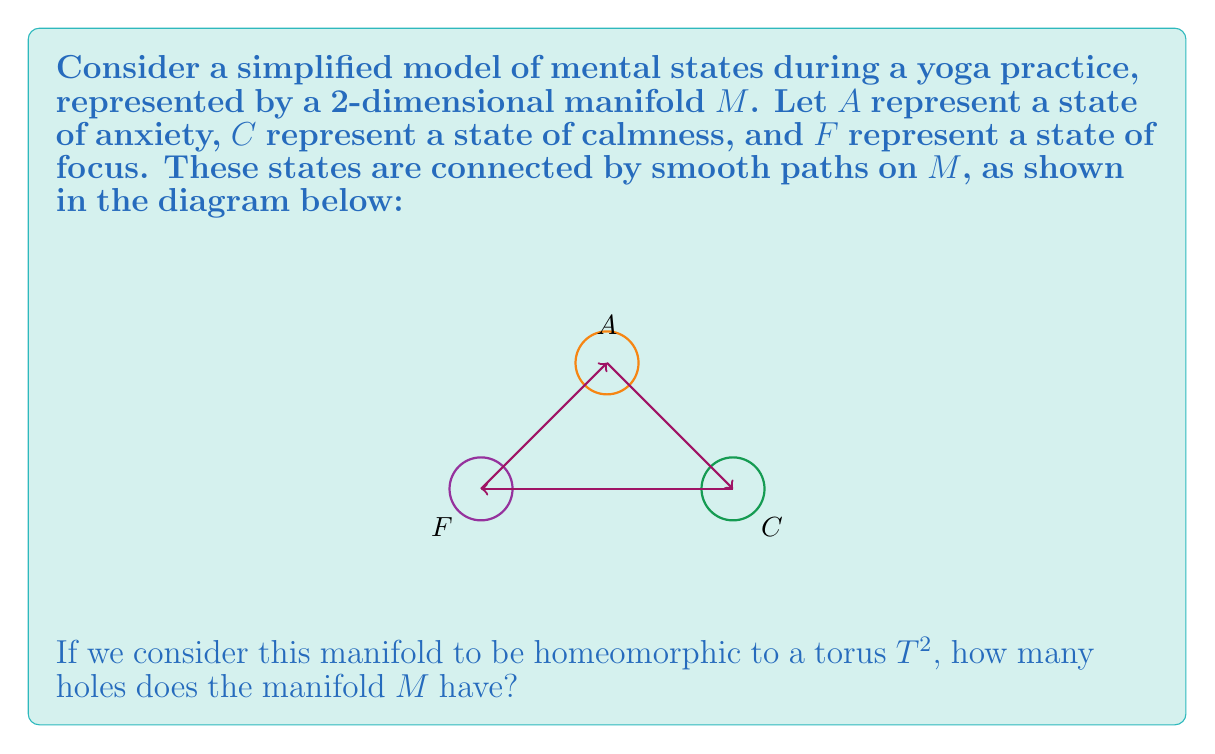Can you solve this math problem? To solve this problem, we need to understand the concept of homeomorphism and the topological properties of a torus:

1. Homeomorphism: Two topological spaces are homeomorphic if there exists a continuous bijection between them with a continuous inverse. Homeomorphic spaces share the same topological properties.

2. Torus properties: A torus $T^2$ is a surface that has the shape of a donut. Topologically, it is characterized by having one hole.

3. Given information: The manifold $M$ is homeomorphic to a torus $T^2$.

4. Topological invariance: The number of holes is a topological invariant, meaning it remains unchanged under homeomorphisms.

5. Conclusion: Since $M$ is homeomorphic to $T^2$, and $T^2$ has one hole, $M$ must also have one hole.

This result implies that the mental states and transitions represented on $M$ have a cyclic nature, which could be interpreted as the continuous flow between anxiety, calmness, and focus during a yoga practice for trauma survivors.
Answer: 1 